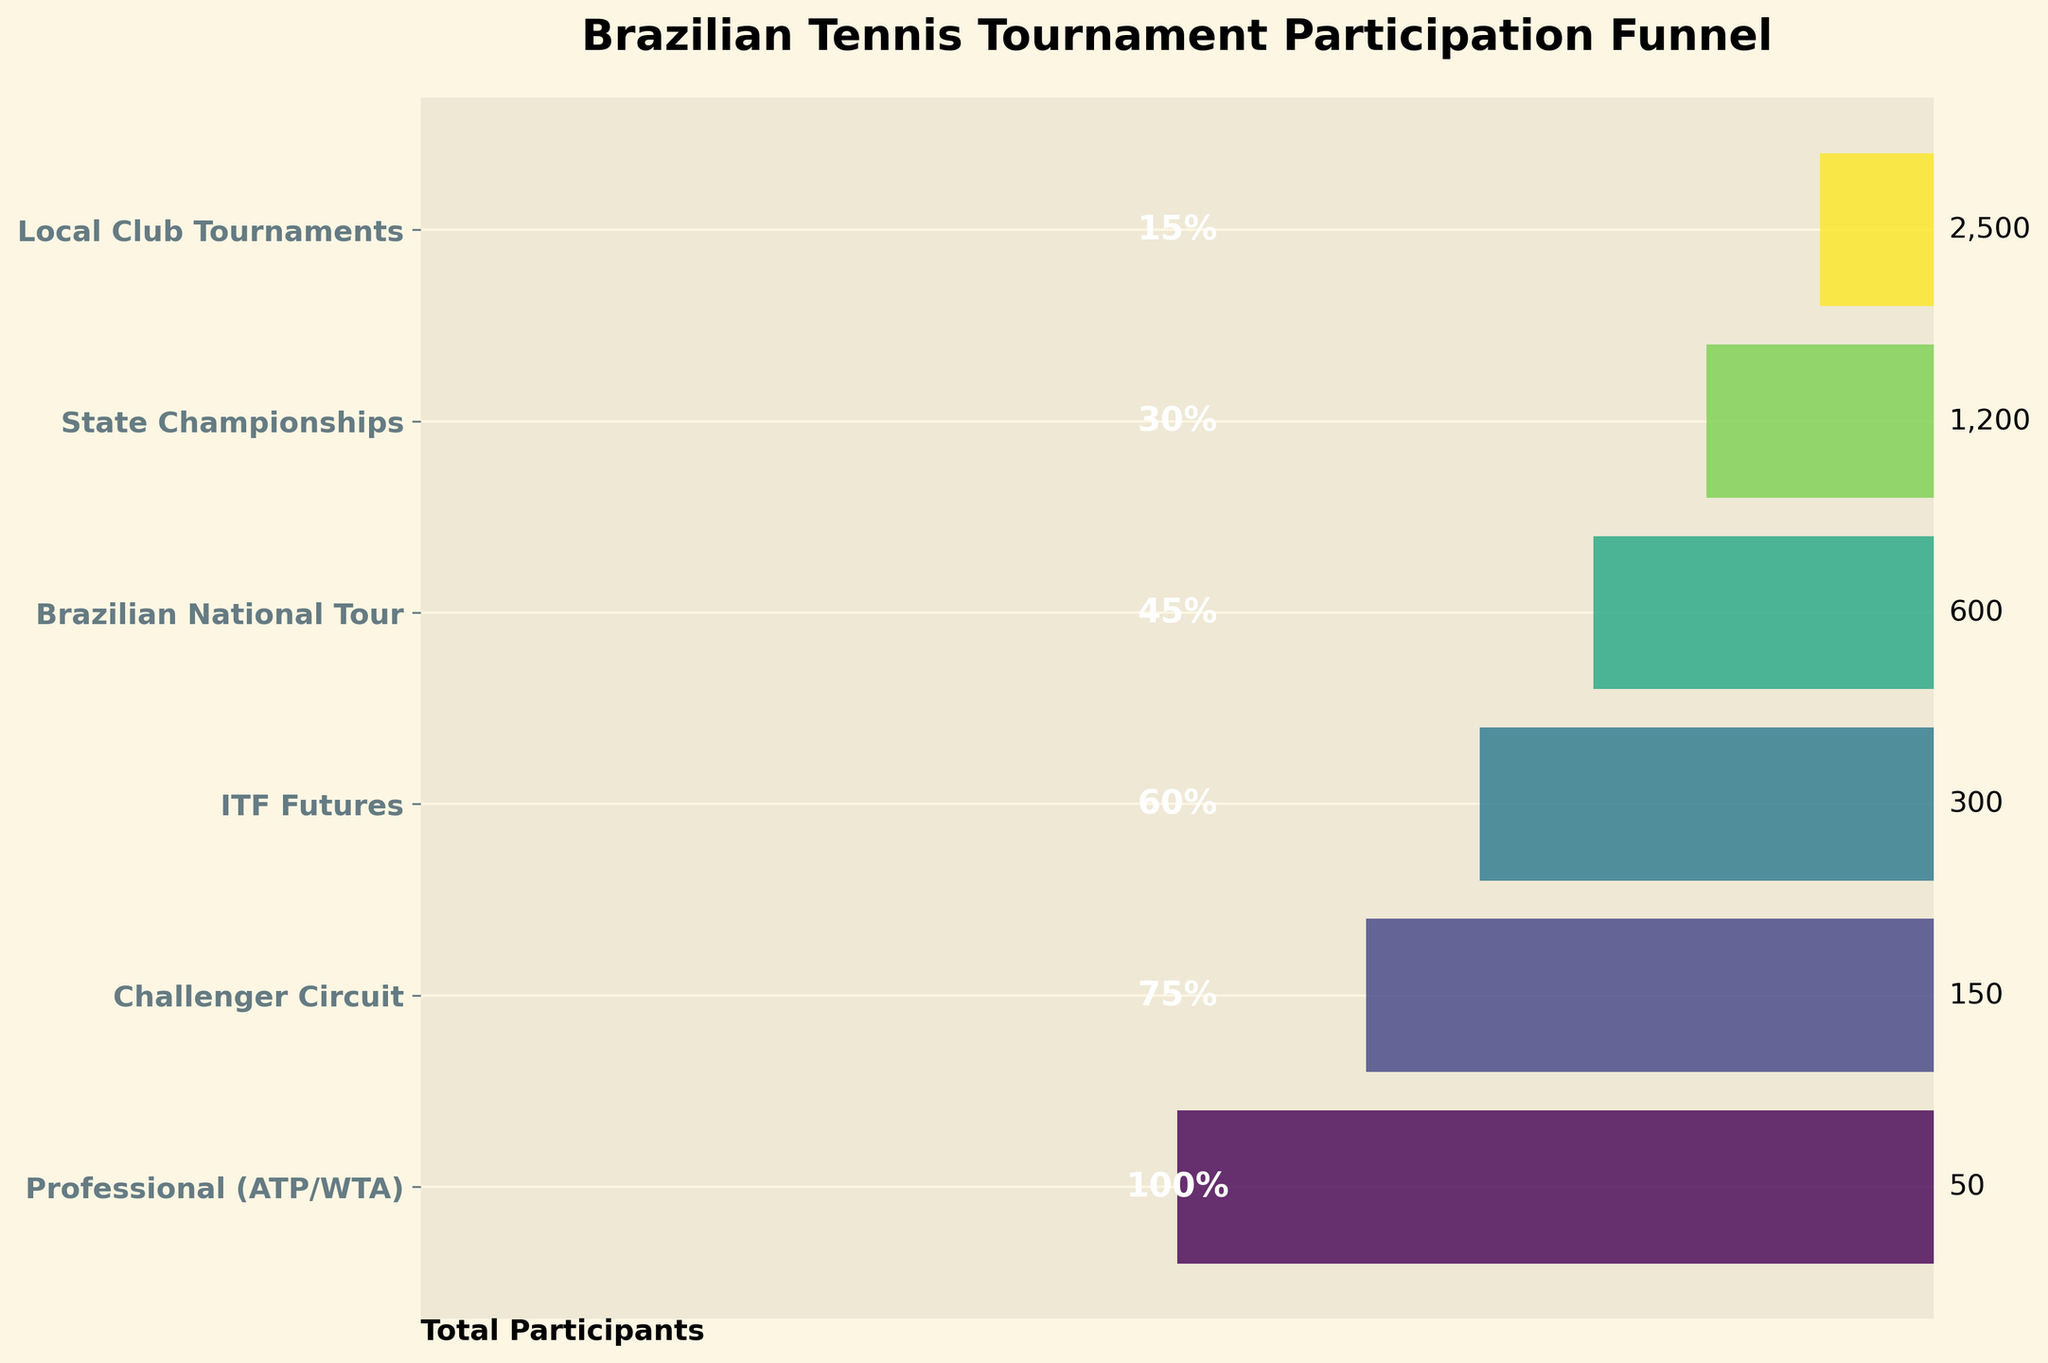What's the title of the chart? The title is displayed at the top of the chart, giving an overview of the content being depicted. In this case, the title is "Brazilian Tennis Tournament Participation Funnel".
Answer: Brazilian Tennis Tournament Participation Funnel What percentage of participants are in the Challenger Circuit? Look at the percentage label next to the "Challenger Circuit" stage in the chart. It shows that 75% of the participants are in this stage.
Answer: 75% How many participants are there in the Professional (ATP/WTA) stage? Look at the participant count next to the "Professional (ATP/WTA)" stage. It shows 50 participants.
Answer: 50 Which stage has the highest number of participants? Compare the participant counts across all stages. The Local Club Tournaments stage has the highest number with 2500 participants.
Answer: Local Club Tournaments Which stage has the lowest percentage of participants in the entire funnel? Compare the percentage labels for all stages. The lowest percentage is 15%, which is for the Local Club Tournaments stage.
Answer: Local Club Tournaments What is the participant difference between the Brazilian National Tour and the State Championships? Subtract the participants in the State Championships (600) from those in the Brazilian National Tour (1200). So, the difference is 1200 - 600 = 600.
Answer: 600 What stages have a higher percentage of participants than the Brazilian National Tour? Check the percentage labels of all stages and compare them to Brazilian National Tour's percentage (45%). The stages with higher percentages are Professional (ATP/WTA) with 100%, Challenger Circuit with 75%, and ITF Futures with 60%.
Answer: Professional (ATP/WTA), Challenger Circuit, ITF Futures Calculate the total number of participants from all stages combined. Sum the number of participants in all stages: 50 + 150 + 300 + 600 + 1200 + 2500 = 4800.
Answer: 4800 What’s the average number of participants in the stages? Sum the number of participants in all stages and then divide by the number of stages: (50 + 150 + 300 + 600 + 1200 + 2500) / 6 = 4800 / 6 = 800.
Answer: 800 